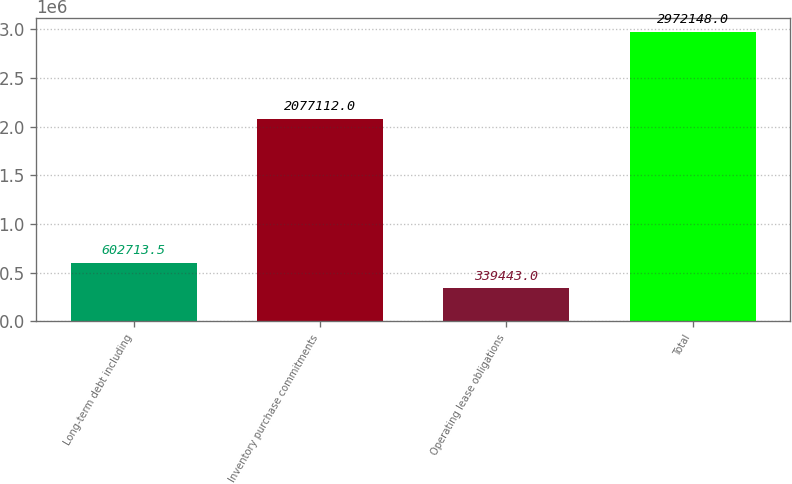Convert chart to OTSL. <chart><loc_0><loc_0><loc_500><loc_500><bar_chart><fcel>Long-term debt including<fcel>Inventory purchase commitments<fcel>Operating lease obligations<fcel>Total<nl><fcel>602714<fcel>2.07711e+06<fcel>339443<fcel>2.97215e+06<nl></chart> 